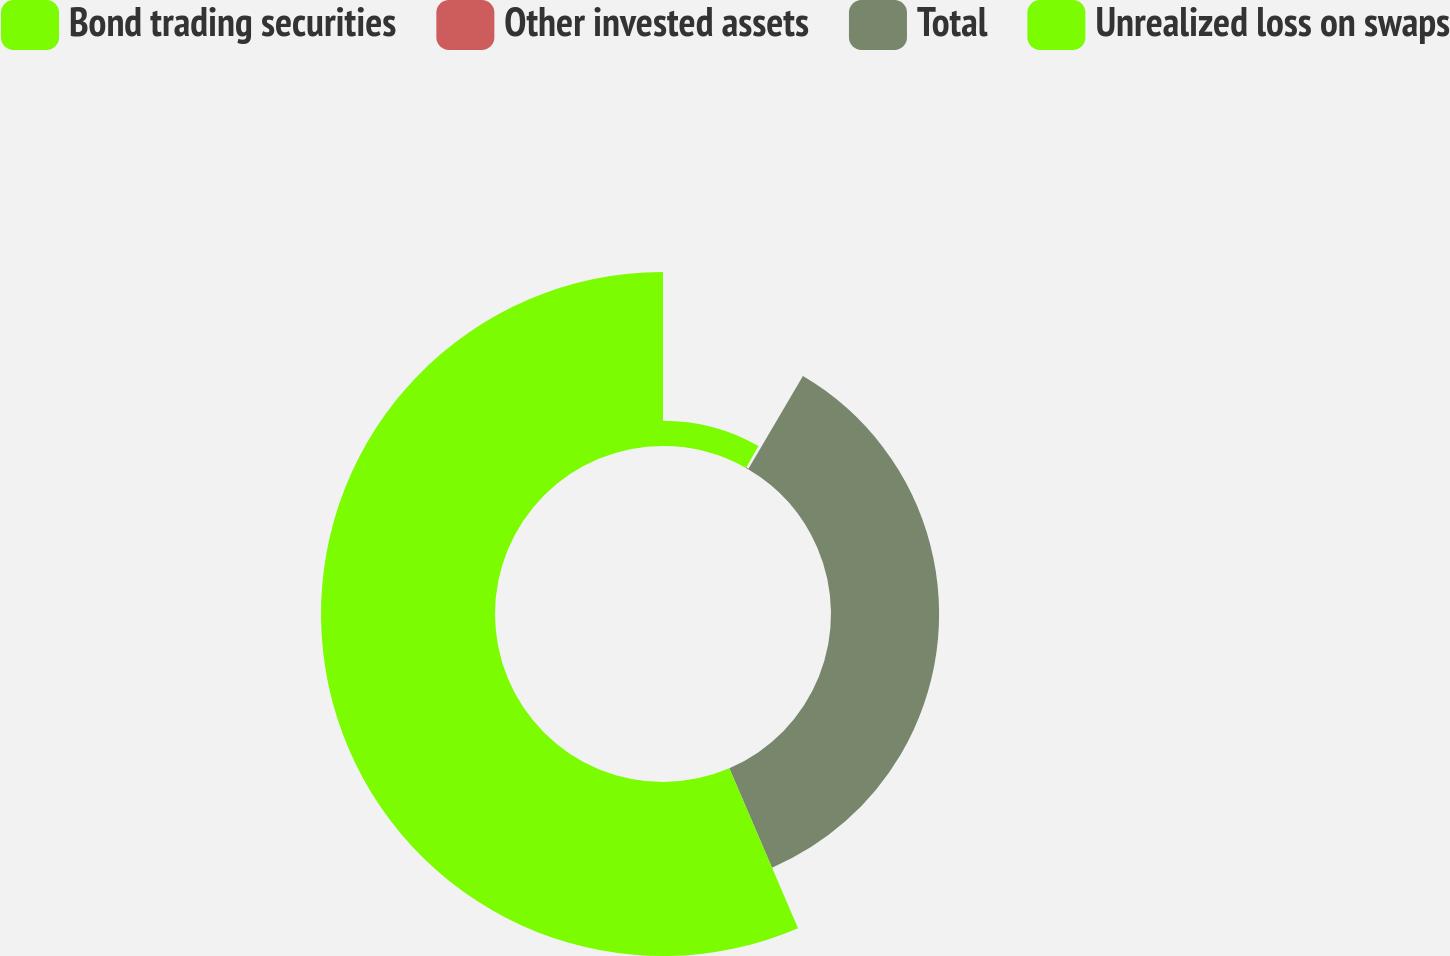<chart> <loc_0><loc_0><loc_500><loc_500><pie_chart><fcel>Bond trading securities<fcel>Other invested assets<fcel>Total<fcel>Unrealized loss on swaps<nl><fcel>8.22%<fcel>0.24%<fcel>35.08%<fcel>56.46%<nl></chart> 